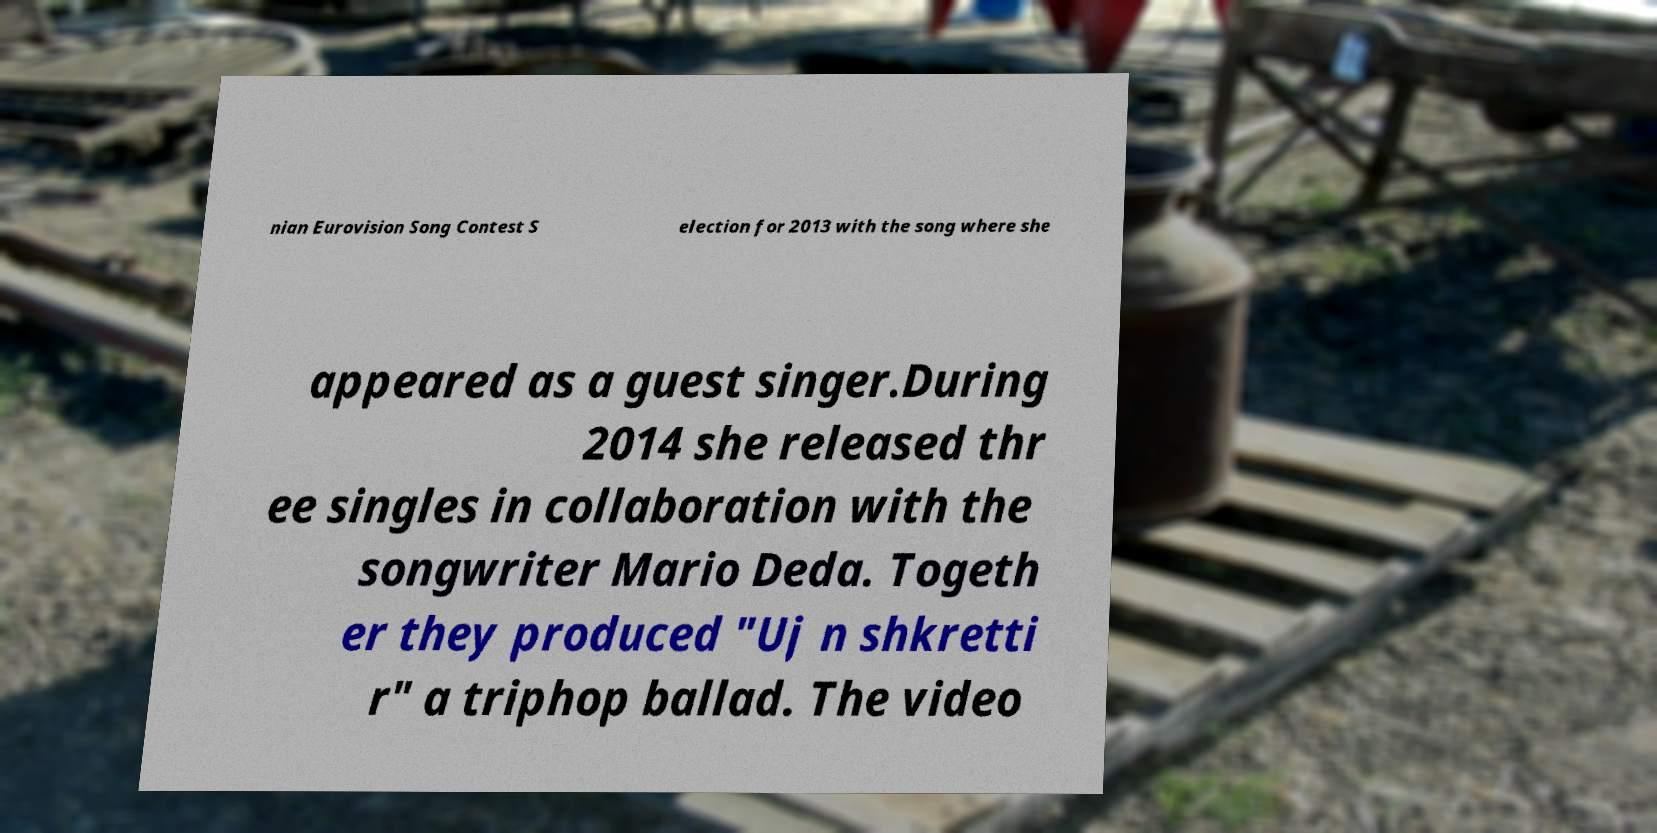What messages or text are displayed in this image? I need them in a readable, typed format. nian Eurovision Song Contest S election for 2013 with the song where she appeared as a guest singer.During 2014 she released thr ee singles in collaboration with the songwriter Mario Deda. Togeth er they produced "Uj n shkretti r" a triphop ballad. The video 